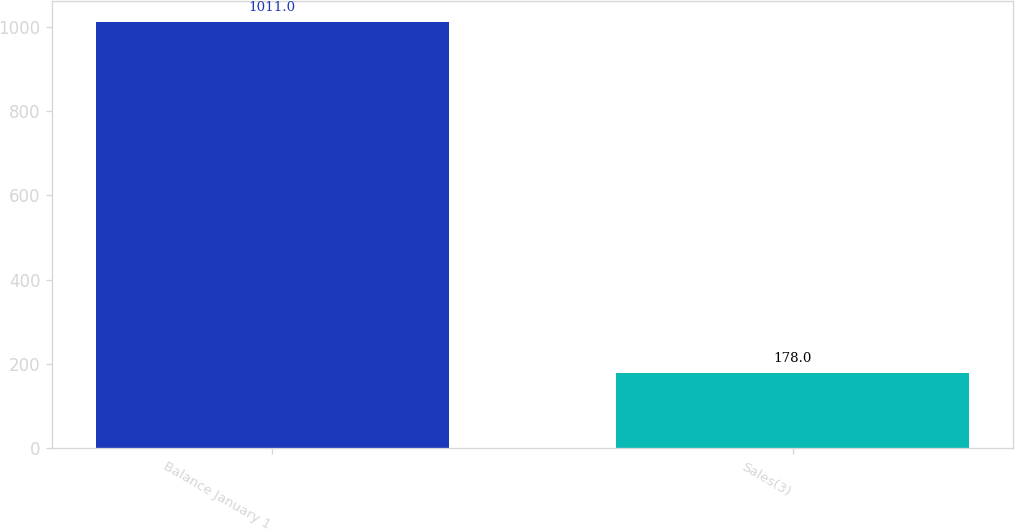<chart> <loc_0><loc_0><loc_500><loc_500><bar_chart><fcel>Balance January 1<fcel>Sales(3)<nl><fcel>1011<fcel>178<nl></chart> 